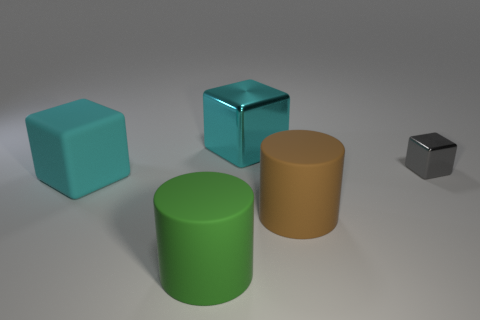There is a big cube that is in front of the cyan shiny block; is it the same color as the large metallic block?
Offer a terse response. Yes. There is a block that is both in front of the large cyan metal object and to the right of the green cylinder; how big is it?
Give a very brief answer. Small. There is a cyan cube in front of the small gray thing; are there any big brown matte things that are to the left of it?
Offer a very short reply. No. The gray shiny object has what size?
Offer a very short reply. Small. What number of objects are cyan matte cubes or tiny gray metallic objects?
Offer a terse response. 2. Is the material of the green object that is right of the large cyan matte cube the same as the object that is to the right of the large brown cylinder?
Keep it short and to the point. No. There is a block that is made of the same material as the brown cylinder; what is its color?
Offer a very short reply. Cyan. How many matte cylinders are the same size as the matte block?
Your answer should be very brief. 2. How many other objects are the same color as the large rubber cube?
Provide a succinct answer. 1. Is there anything else that is the same size as the cyan shiny block?
Keep it short and to the point. Yes. 